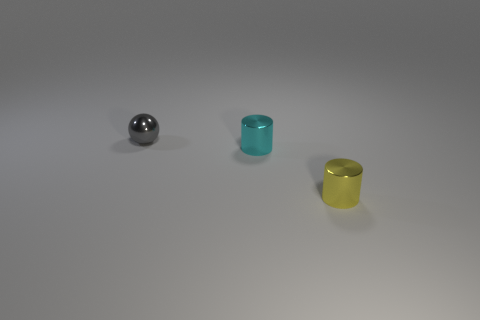Add 1 small cyan cylinders. How many objects exist? 4 Subtract all balls. How many objects are left? 2 Subtract all metallic cylinders. Subtract all shiny balls. How many objects are left? 0 Add 1 metal objects. How many metal objects are left? 4 Add 1 cylinders. How many cylinders exist? 3 Subtract 0 green cylinders. How many objects are left? 3 